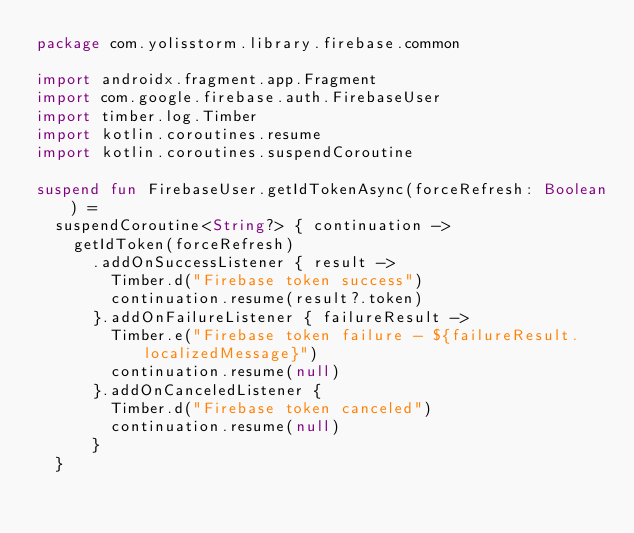<code> <loc_0><loc_0><loc_500><loc_500><_Kotlin_>package com.yolisstorm.library.firebase.common

import androidx.fragment.app.Fragment
import com.google.firebase.auth.FirebaseUser
import timber.log.Timber
import kotlin.coroutines.resume
import kotlin.coroutines.suspendCoroutine

suspend fun FirebaseUser.getIdTokenAsync(forceRefresh: Boolean) =
	suspendCoroutine<String?> { continuation ->
		getIdToken(forceRefresh)
			.addOnSuccessListener { result ->
				Timber.d("Firebase token success")
				continuation.resume(result?.token)
			}.addOnFailureListener { failureResult ->
				Timber.e("Firebase token failure - ${failureResult.localizedMessage}")
				continuation.resume(null)
			}.addOnCanceledListener {
				Timber.d("Firebase token canceled")
				continuation.resume(null)
			}
	}
</code> 